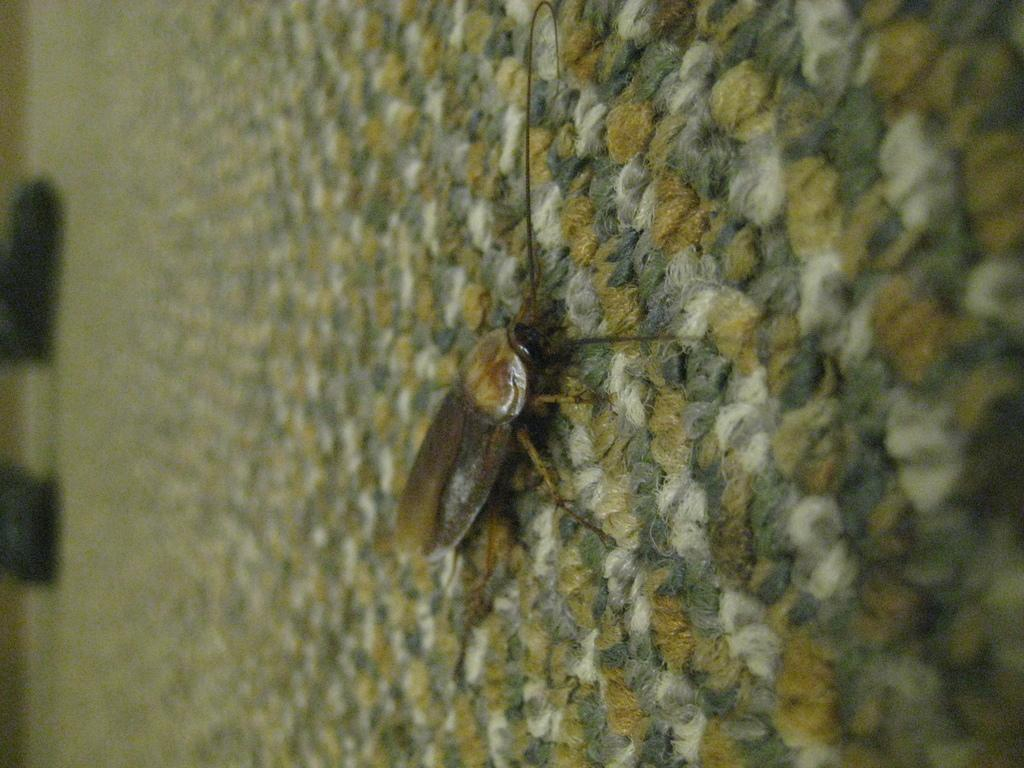What is the main subject of the picture? The main subject of the picture is a cockroach. Where is the cockroach located in the image? The cockroach is on a mat in the center of the picture. Can you describe the edges of the image? The edges of the image are blurred. How many apples are on the arch in the image? There are no apples or arches present in the image; it features a cockroach on a mat. What type of pigs can be seen playing with the cockroach in the image? There are no pigs present in the image, and the cockroach is not interacting with any other animals. 